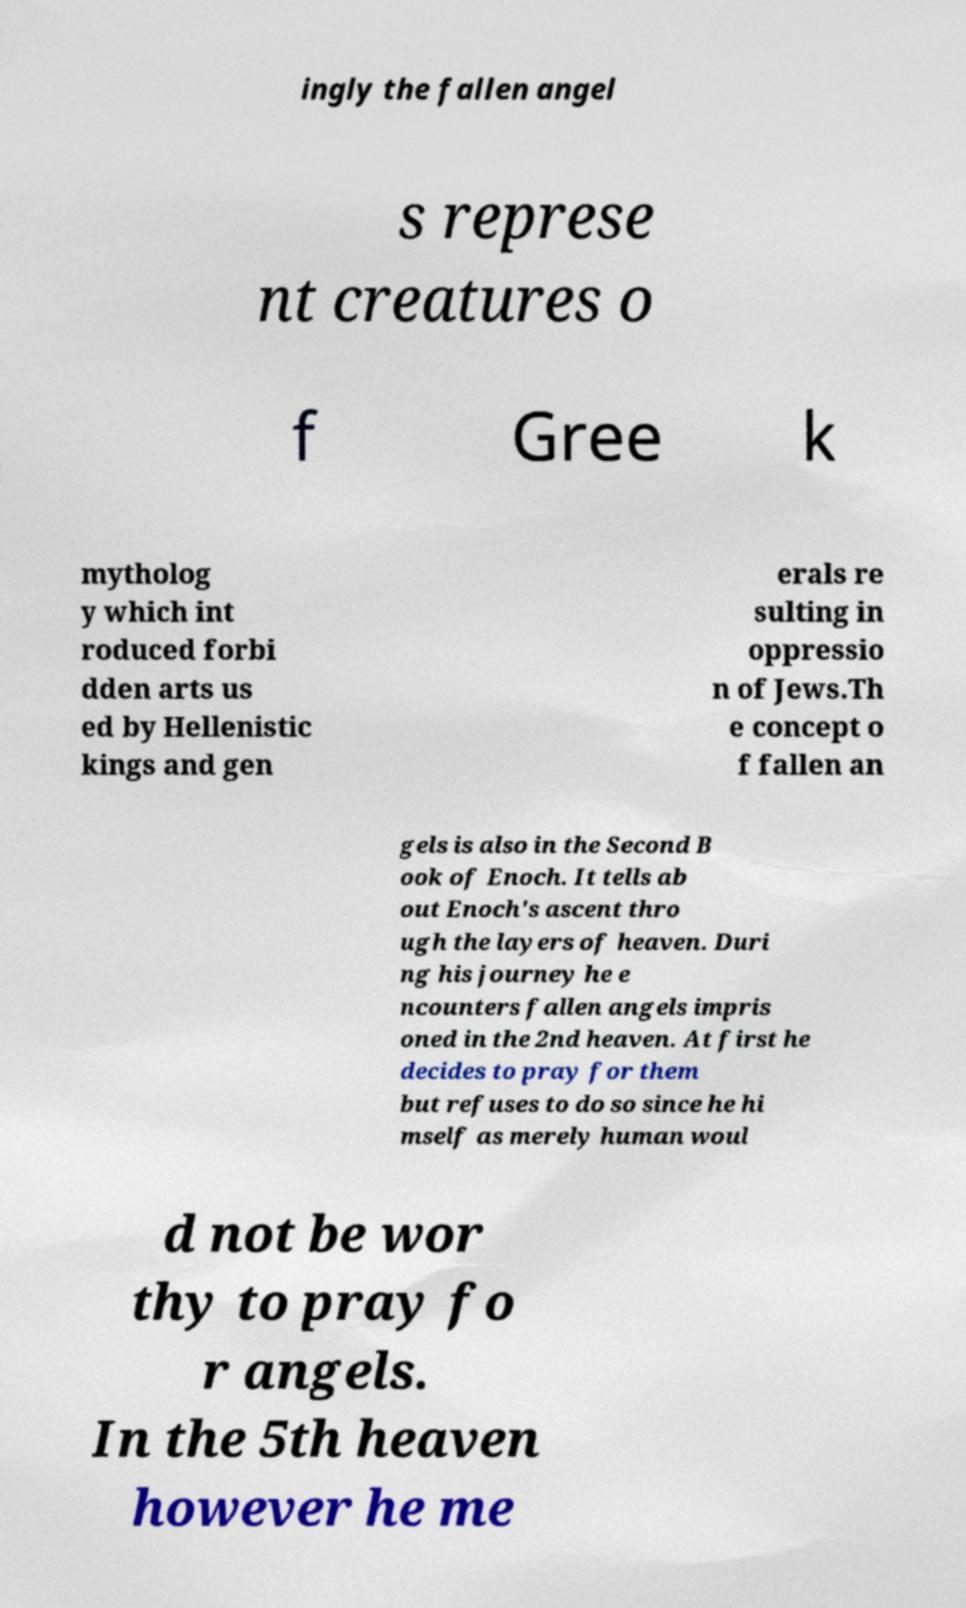For documentation purposes, I need the text within this image transcribed. Could you provide that? ingly the fallen angel s represe nt creatures o f Gree k mytholog y which int roduced forbi dden arts us ed by Hellenistic kings and gen erals re sulting in oppressio n of Jews.Th e concept o f fallen an gels is also in the Second B ook of Enoch. It tells ab out Enoch's ascent thro ugh the layers of heaven. Duri ng his journey he e ncounters fallen angels impris oned in the 2nd heaven. At first he decides to pray for them but refuses to do so since he hi mself as merely human woul d not be wor thy to pray fo r angels. In the 5th heaven however he me 